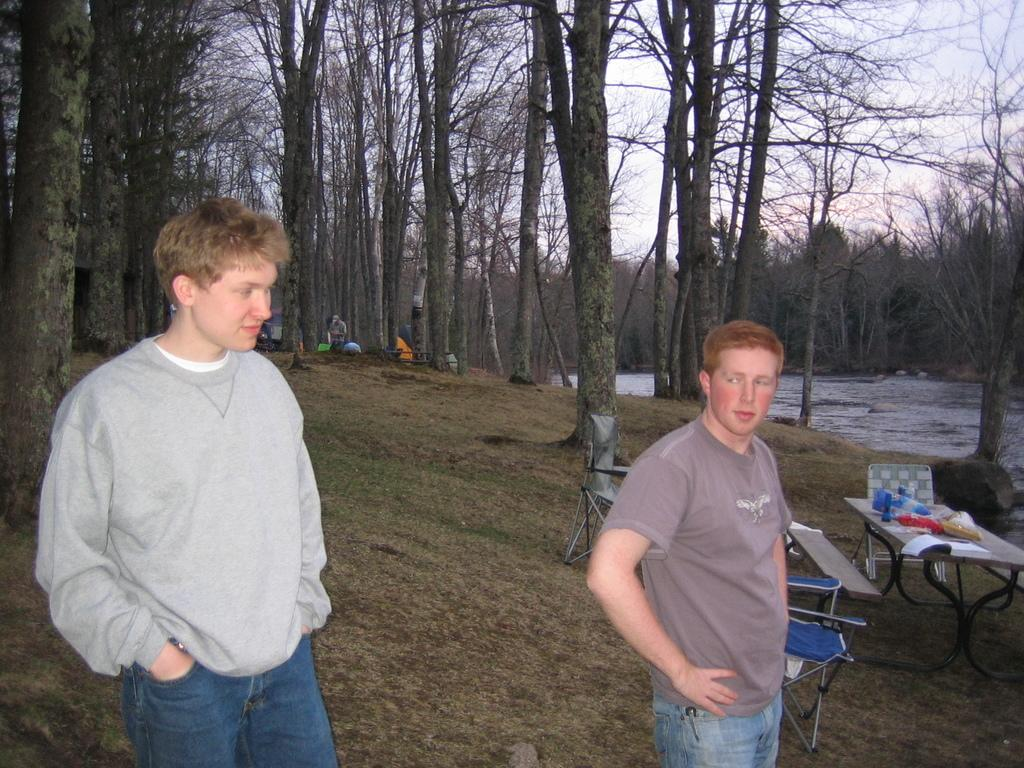What can be seen in the foreground of the image? There are men standing in the front of the image. What is visible in the background of the image? There are trees and a river in the background of the image. What type of soda is being advertised by the actor in the image? There is no actor or soda present in the image; it features men standing in front of a background with trees and a river. 